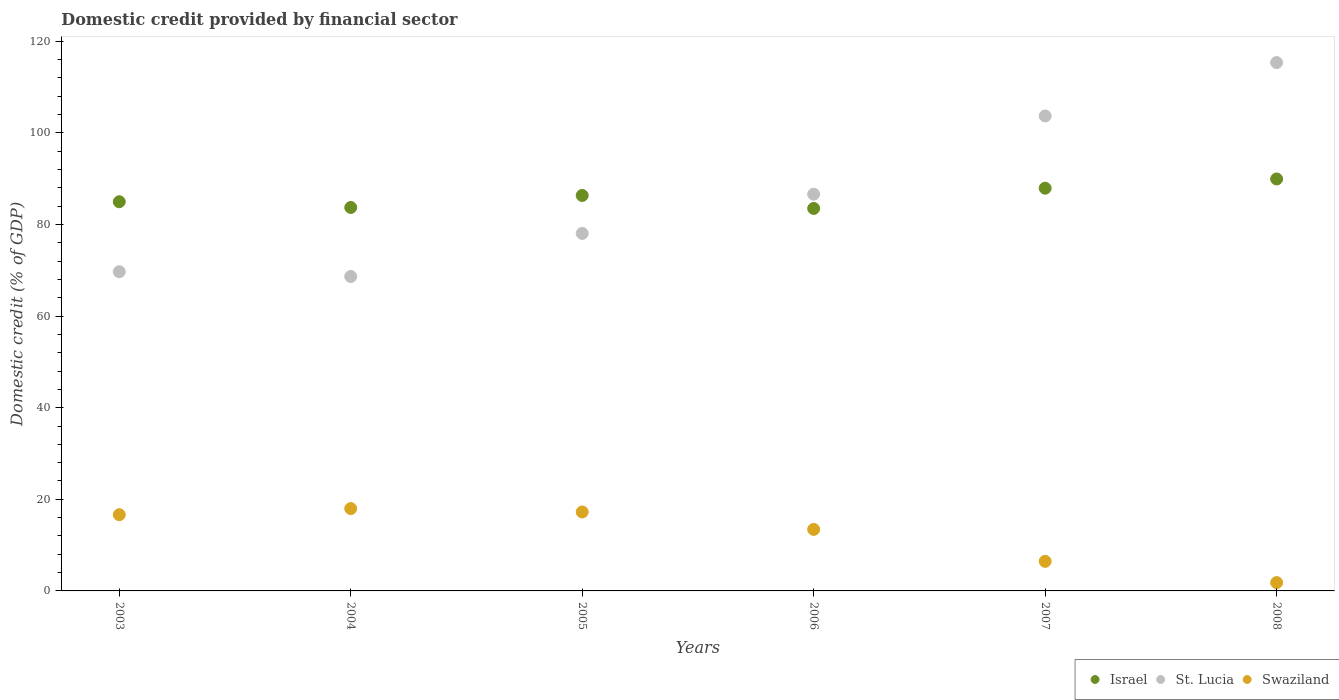What is the domestic credit in Swaziland in 2006?
Your answer should be very brief. 13.43. Across all years, what is the maximum domestic credit in St. Lucia?
Your response must be concise. 115.35. Across all years, what is the minimum domestic credit in Israel?
Make the answer very short. 83.51. In which year was the domestic credit in St. Lucia maximum?
Ensure brevity in your answer.  2008. What is the total domestic credit in St. Lucia in the graph?
Your response must be concise. 522.05. What is the difference between the domestic credit in Israel in 2003 and that in 2008?
Your answer should be very brief. -4.97. What is the difference between the domestic credit in St. Lucia in 2006 and the domestic credit in Israel in 2003?
Provide a succinct answer. 1.64. What is the average domestic credit in Swaziland per year?
Provide a short and direct response. 12.26. In the year 2003, what is the difference between the domestic credit in Israel and domestic credit in St. Lucia?
Your answer should be very brief. 15.28. In how many years, is the domestic credit in Swaziland greater than 32 %?
Give a very brief answer. 0. What is the ratio of the domestic credit in Swaziland in 2005 to that in 2007?
Offer a terse response. 2.67. What is the difference between the highest and the second highest domestic credit in St. Lucia?
Ensure brevity in your answer.  11.65. What is the difference between the highest and the lowest domestic credit in St. Lucia?
Offer a terse response. 46.7. In how many years, is the domestic credit in Israel greater than the average domestic credit in Israel taken over all years?
Your response must be concise. 3. What is the difference between two consecutive major ticks on the Y-axis?
Provide a succinct answer. 20. Does the graph contain grids?
Your response must be concise. No. Where does the legend appear in the graph?
Make the answer very short. Bottom right. How are the legend labels stacked?
Offer a very short reply. Horizontal. What is the title of the graph?
Your answer should be compact. Domestic credit provided by financial sector. What is the label or title of the Y-axis?
Offer a terse response. Domestic credit (% of GDP). What is the Domestic credit (% of GDP) in Israel in 2003?
Provide a short and direct response. 84.97. What is the Domestic credit (% of GDP) in St. Lucia in 2003?
Give a very brief answer. 69.7. What is the Domestic credit (% of GDP) in Swaziland in 2003?
Your answer should be very brief. 16.64. What is the Domestic credit (% of GDP) of Israel in 2004?
Your response must be concise. 83.72. What is the Domestic credit (% of GDP) in St. Lucia in 2004?
Offer a terse response. 68.65. What is the Domestic credit (% of GDP) in Swaziland in 2004?
Keep it short and to the point. 17.98. What is the Domestic credit (% of GDP) in Israel in 2005?
Make the answer very short. 86.34. What is the Domestic credit (% of GDP) of St. Lucia in 2005?
Keep it short and to the point. 78.05. What is the Domestic credit (% of GDP) in Swaziland in 2005?
Provide a short and direct response. 17.24. What is the Domestic credit (% of GDP) in Israel in 2006?
Keep it short and to the point. 83.51. What is the Domestic credit (% of GDP) of St. Lucia in 2006?
Make the answer very short. 86.61. What is the Domestic credit (% of GDP) in Swaziland in 2006?
Offer a very short reply. 13.43. What is the Domestic credit (% of GDP) of Israel in 2007?
Your answer should be compact. 87.92. What is the Domestic credit (% of GDP) in St. Lucia in 2007?
Provide a short and direct response. 103.7. What is the Domestic credit (% of GDP) in Swaziland in 2007?
Give a very brief answer. 6.46. What is the Domestic credit (% of GDP) of Israel in 2008?
Your answer should be very brief. 89.94. What is the Domestic credit (% of GDP) of St. Lucia in 2008?
Provide a short and direct response. 115.35. What is the Domestic credit (% of GDP) in Swaziland in 2008?
Ensure brevity in your answer.  1.82. Across all years, what is the maximum Domestic credit (% of GDP) in Israel?
Ensure brevity in your answer.  89.94. Across all years, what is the maximum Domestic credit (% of GDP) of St. Lucia?
Make the answer very short. 115.35. Across all years, what is the maximum Domestic credit (% of GDP) in Swaziland?
Keep it short and to the point. 17.98. Across all years, what is the minimum Domestic credit (% of GDP) in Israel?
Give a very brief answer. 83.51. Across all years, what is the minimum Domestic credit (% of GDP) of St. Lucia?
Provide a short and direct response. 68.65. Across all years, what is the minimum Domestic credit (% of GDP) of Swaziland?
Your response must be concise. 1.82. What is the total Domestic credit (% of GDP) in Israel in the graph?
Offer a very short reply. 516.39. What is the total Domestic credit (% of GDP) of St. Lucia in the graph?
Make the answer very short. 522.05. What is the total Domestic credit (% of GDP) in Swaziland in the graph?
Offer a terse response. 73.56. What is the difference between the Domestic credit (% of GDP) of Israel in 2003 and that in 2004?
Offer a very short reply. 1.26. What is the difference between the Domestic credit (% of GDP) in St. Lucia in 2003 and that in 2004?
Keep it short and to the point. 1.05. What is the difference between the Domestic credit (% of GDP) in Swaziland in 2003 and that in 2004?
Your response must be concise. -1.33. What is the difference between the Domestic credit (% of GDP) in Israel in 2003 and that in 2005?
Provide a short and direct response. -1.37. What is the difference between the Domestic credit (% of GDP) of St. Lucia in 2003 and that in 2005?
Your answer should be compact. -8.36. What is the difference between the Domestic credit (% of GDP) of Swaziland in 2003 and that in 2005?
Ensure brevity in your answer.  -0.59. What is the difference between the Domestic credit (% of GDP) in Israel in 2003 and that in 2006?
Your answer should be very brief. 1.47. What is the difference between the Domestic credit (% of GDP) in St. Lucia in 2003 and that in 2006?
Give a very brief answer. -16.92. What is the difference between the Domestic credit (% of GDP) in Swaziland in 2003 and that in 2006?
Offer a very short reply. 3.22. What is the difference between the Domestic credit (% of GDP) of Israel in 2003 and that in 2007?
Provide a succinct answer. -2.95. What is the difference between the Domestic credit (% of GDP) in St. Lucia in 2003 and that in 2007?
Make the answer very short. -34. What is the difference between the Domestic credit (% of GDP) in Swaziland in 2003 and that in 2007?
Ensure brevity in your answer.  10.18. What is the difference between the Domestic credit (% of GDP) of Israel in 2003 and that in 2008?
Keep it short and to the point. -4.97. What is the difference between the Domestic credit (% of GDP) in St. Lucia in 2003 and that in 2008?
Your response must be concise. -45.65. What is the difference between the Domestic credit (% of GDP) of Swaziland in 2003 and that in 2008?
Give a very brief answer. 14.83. What is the difference between the Domestic credit (% of GDP) in Israel in 2004 and that in 2005?
Provide a short and direct response. -2.62. What is the difference between the Domestic credit (% of GDP) of St. Lucia in 2004 and that in 2005?
Your response must be concise. -9.4. What is the difference between the Domestic credit (% of GDP) of Swaziland in 2004 and that in 2005?
Your answer should be very brief. 0.74. What is the difference between the Domestic credit (% of GDP) in Israel in 2004 and that in 2006?
Your answer should be compact. 0.21. What is the difference between the Domestic credit (% of GDP) of St. Lucia in 2004 and that in 2006?
Provide a short and direct response. -17.97. What is the difference between the Domestic credit (% of GDP) of Swaziland in 2004 and that in 2006?
Offer a very short reply. 4.55. What is the difference between the Domestic credit (% of GDP) of Israel in 2004 and that in 2007?
Your answer should be very brief. -4.21. What is the difference between the Domestic credit (% of GDP) in St. Lucia in 2004 and that in 2007?
Keep it short and to the point. -35.05. What is the difference between the Domestic credit (% of GDP) of Swaziland in 2004 and that in 2007?
Provide a short and direct response. 11.52. What is the difference between the Domestic credit (% of GDP) of Israel in 2004 and that in 2008?
Your response must be concise. -6.22. What is the difference between the Domestic credit (% of GDP) in St. Lucia in 2004 and that in 2008?
Keep it short and to the point. -46.7. What is the difference between the Domestic credit (% of GDP) of Swaziland in 2004 and that in 2008?
Ensure brevity in your answer.  16.16. What is the difference between the Domestic credit (% of GDP) of Israel in 2005 and that in 2006?
Give a very brief answer. 2.83. What is the difference between the Domestic credit (% of GDP) of St. Lucia in 2005 and that in 2006?
Make the answer very short. -8.56. What is the difference between the Domestic credit (% of GDP) in Swaziland in 2005 and that in 2006?
Make the answer very short. 3.81. What is the difference between the Domestic credit (% of GDP) of Israel in 2005 and that in 2007?
Your response must be concise. -1.58. What is the difference between the Domestic credit (% of GDP) in St. Lucia in 2005 and that in 2007?
Give a very brief answer. -25.64. What is the difference between the Domestic credit (% of GDP) of Swaziland in 2005 and that in 2007?
Provide a short and direct response. 10.78. What is the difference between the Domestic credit (% of GDP) of Israel in 2005 and that in 2008?
Your answer should be very brief. -3.6. What is the difference between the Domestic credit (% of GDP) of St. Lucia in 2005 and that in 2008?
Offer a very short reply. -37.3. What is the difference between the Domestic credit (% of GDP) in Swaziland in 2005 and that in 2008?
Provide a short and direct response. 15.42. What is the difference between the Domestic credit (% of GDP) in Israel in 2006 and that in 2007?
Offer a very short reply. -4.42. What is the difference between the Domestic credit (% of GDP) of St. Lucia in 2006 and that in 2007?
Your response must be concise. -17.08. What is the difference between the Domestic credit (% of GDP) of Swaziland in 2006 and that in 2007?
Your answer should be compact. 6.97. What is the difference between the Domestic credit (% of GDP) in Israel in 2006 and that in 2008?
Keep it short and to the point. -6.43. What is the difference between the Domestic credit (% of GDP) in St. Lucia in 2006 and that in 2008?
Your answer should be very brief. -28.73. What is the difference between the Domestic credit (% of GDP) of Swaziland in 2006 and that in 2008?
Provide a succinct answer. 11.61. What is the difference between the Domestic credit (% of GDP) in Israel in 2007 and that in 2008?
Your response must be concise. -2.02. What is the difference between the Domestic credit (% of GDP) of St. Lucia in 2007 and that in 2008?
Give a very brief answer. -11.65. What is the difference between the Domestic credit (% of GDP) of Swaziland in 2007 and that in 2008?
Your answer should be very brief. 4.64. What is the difference between the Domestic credit (% of GDP) in Israel in 2003 and the Domestic credit (% of GDP) in St. Lucia in 2004?
Provide a short and direct response. 16.32. What is the difference between the Domestic credit (% of GDP) in Israel in 2003 and the Domestic credit (% of GDP) in Swaziland in 2004?
Your response must be concise. 67. What is the difference between the Domestic credit (% of GDP) of St. Lucia in 2003 and the Domestic credit (% of GDP) of Swaziland in 2004?
Ensure brevity in your answer.  51.72. What is the difference between the Domestic credit (% of GDP) of Israel in 2003 and the Domestic credit (% of GDP) of St. Lucia in 2005?
Your response must be concise. 6.92. What is the difference between the Domestic credit (% of GDP) of Israel in 2003 and the Domestic credit (% of GDP) of Swaziland in 2005?
Your answer should be very brief. 67.73. What is the difference between the Domestic credit (% of GDP) in St. Lucia in 2003 and the Domestic credit (% of GDP) in Swaziland in 2005?
Offer a very short reply. 52.46. What is the difference between the Domestic credit (% of GDP) in Israel in 2003 and the Domestic credit (% of GDP) in St. Lucia in 2006?
Offer a terse response. -1.64. What is the difference between the Domestic credit (% of GDP) in Israel in 2003 and the Domestic credit (% of GDP) in Swaziland in 2006?
Make the answer very short. 71.54. What is the difference between the Domestic credit (% of GDP) in St. Lucia in 2003 and the Domestic credit (% of GDP) in Swaziland in 2006?
Offer a terse response. 56.27. What is the difference between the Domestic credit (% of GDP) of Israel in 2003 and the Domestic credit (% of GDP) of St. Lucia in 2007?
Your answer should be compact. -18.72. What is the difference between the Domestic credit (% of GDP) in Israel in 2003 and the Domestic credit (% of GDP) in Swaziland in 2007?
Provide a short and direct response. 78.51. What is the difference between the Domestic credit (% of GDP) of St. Lucia in 2003 and the Domestic credit (% of GDP) of Swaziland in 2007?
Your response must be concise. 63.24. What is the difference between the Domestic credit (% of GDP) of Israel in 2003 and the Domestic credit (% of GDP) of St. Lucia in 2008?
Make the answer very short. -30.38. What is the difference between the Domestic credit (% of GDP) of Israel in 2003 and the Domestic credit (% of GDP) of Swaziland in 2008?
Provide a succinct answer. 83.15. What is the difference between the Domestic credit (% of GDP) in St. Lucia in 2003 and the Domestic credit (% of GDP) in Swaziland in 2008?
Your response must be concise. 67.88. What is the difference between the Domestic credit (% of GDP) of Israel in 2004 and the Domestic credit (% of GDP) of St. Lucia in 2005?
Offer a very short reply. 5.66. What is the difference between the Domestic credit (% of GDP) of Israel in 2004 and the Domestic credit (% of GDP) of Swaziland in 2005?
Keep it short and to the point. 66.48. What is the difference between the Domestic credit (% of GDP) of St. Lucia in 2004 and the Domestic credit (% of GDP) of Swaziland in 2005?
Ensure brevity in your answer.  51.41. What is the difference between the Domestic credit (% of GDP) in Israel in 2004 and the Domestic credit (% of GDP) in St. Lucia in 2006?
Make the answer very short. -2.9. What is the difference between the Domestic credit (% of GDP) in Israel in 2004 and the Domestic credit (% of GDP) in Swaziland in 2006?
Give a very brief answer. 70.29. What is the difference between the Domestic credit (% of GDP) of St. Lucia in 2004 and the Domestic credit (% of GDP) of Swaziland in 2006?
Your answer should be very brief. 55.22. What is the difference between the Domestic credit (% of GDP) of Israel in 2004 and the Domestic credit (% of GDP) of St. Lucia in 2007?
Make the answer very short. -19.98. What is the difference between the Domestic credit (% of GDP) of Israel in 2004 and the Domestic credit (% of GDP) of Swaziland in 2007?
Provide a succinct answer. 77.26. What is the difference between the Domestic credit (% of GDP) in St. Lucia in 2004 and the Domestic credit (% of GDP) in Swaziland in 2007?
Your answer should be compact. 62.19. What is the difference between the Domestic credit (% of GDP) in Israel in 2004 and the Domestic credit (% of GDP) in St. Lucia in 2008?
Your response must be concise. -31.63. What is the difference between the Domestic credit (% of GDP) of Israel in 2004 and the Domestic credit (% of GDP) of Swaziland in 2008?
Offer a very short reply. 81.9. What is the difference between the Domestic credit (% of GDP) in St. Lucia in 2004 and the Domestic credit (% of GDP) in Swaziland in 2008?
Ensure brevity in your answer.  66.83. What is the difference between the Domestic credit (% of GDP) of Israel in 2005 and the Domestic credit (% of GDP) of St. Lucia in 2006?
Ensure brevity in your answer.  -0.28. What is the difference between the Domestic credit (% of GDP) in Israel in 2005 and the Domestic credit (% of GDP) in Swaziland in 2006?
Ensure brevity in your answer.  72.91. What is the difference between the Domestic credit (% of GDP) in St. Lucia in 2005 and the Domestic credit (% of GDP) in Swaziland in 2006?
Give a very brief answer. 64.62. What is the difference between the Domestic credit (% of GDP) in Israel in 2005 and the Domestic credit (% of GDP) in St. Lucia in 2007?
Your response must be concise. -17.36. What is the difference between the Domestic credit (% of GDP) of Israel in 2005 and the Domestic credit (% of GDP) of Swaziland in 2007?
Your answer should be compact. 79.88. What is the difference between the Domestic credit (% of GDP) of St. Lucia in 2005 and the Domestic credit (% of GDP) of Swaziland in 2007?
Provide a succinct answer. 71.59. What is the difference between the Domestic credit (% of GDP) of Israel in 2005 and the Domestic credit (% of GDP) of St. Lucia in 2008?
Your answer should be very brief. -29.01. What is the difference between the Domestic credit (% of GDP) in Israel in 2005 and the Domestic credit (% of GDP) in Swaziland in 2008?
Give a very brief answer. 84.52. What is the difference between the Domestic credit (% of GDP) of St. Lucia in 2005 and the Domestic credit (% of GDP) of Swaziland in 2008?
Provide a short and direct response. 76.23. What is the difference between the Domestic credit (% of GDP) of Israel in 2006 and the Domestic credit (% of GDP) of St. Lucia in 2007?
Offer a terse response. -20.19. What is the difference between the Domestic credit (% of GDP) in Israel in 2006 and the Domestic credit (% of GDP) in Swaziland in 2007?
Your answer should be compact. 77.05. What is the difference between the Domestic credit (% of GDP) of St. Lucia in 2006 and the Domestic credit (% of GDP) of Swaziland in 2007?
Your answer should be compact. 80.15. What is the difference between the Domestic credit (% of GDP) of Israel in 2006 and the Domestic credit (% of GDP) of St. Lucia in 2008?
Offer a terse response. -31.84. What is the difference between the Domestic credit (% of GDP) of Israel in 2006 and the Domestic credit (% of GDP) of Swaziland in 2008?
Ensure brevity in your answer.  81.69. What is the difference between the Domestic credit (% of GDP) of St. Lucia in 2006 and the Domestic credit (% of GDP) of Swaziland in 2008?
Your response must be concise. 84.8. What is the difference between the Domestic credit (% of GDP) of Israel in 2007 and the Domestic credit (% of GDP) of St. Lucia in 2008?
Keep it short and to the point. -27.43. What is the difference between the Domestic credit (% of GDP) in Israel in 2007 and the Domestic credit (% of GDP) in Swaziland in 2008?
Your answer should be very brief. 86.1. What is the difference between the Domestic credit (% of GDP) of St. Lucia in 2007 and the Domestic credit (% of GDP) of Swaziland in 2008?
Your answer should be compact. 101.88. What is the average Domestic credit (% of GDP) of Israel per year?
Offer a terse response. 86.06. What is the average Domestic credit (% of GDP) in St. Lucia per year?
Provide a succinct answer. 87.01. What is the average Domestic credit (% of GDP) in Swaziland per year?
Ensure brevity in your answer.  12.26. In the year 2003, what is the difference between the Domestic credit (% of GDP) of Israel and Domestic credit (% of GDP) of St. Lucia?
Offer a very short reply. 15.28. In the year 2003, what is the difference between the Domestic credit (% of GDP) in Israel and Domestic credit (% of GDP) in Swaziland?
Your response must be concise. 68.33. In the year 2003, what is the difference between the Domestic credit (% of GDP) in St. Lucia and Domestic credit (% of GDP) in Swaziland?
Provide a succinct answer. 53.05. In the year 2004, what is the difference between the Domestic credit (% of GDP) of Israel and Domestic credit (% of GDP) of St. Lucia?
Make the answer very short. 15.07. In the year 2004, what is the difference between the Domestic credit (% of GDP) of Israel and Domestic credit (% of GDP) of Swaziland?
Provide a short and direct response. 65.74. In the year 2004, what is the difference between the Domestic credit (% of GDP) in St. Lucia and Domestic credit (% of GDP) in Swaziland?
Keep it short and to the point. 50.67. In the year 2005, what is the difference between the Domestic credit (% of GDP) in Israel and Domestic credit (% of GDP) in St. Lucia?
Offer a very short reply. 8.29. In the year 2005, what is the difference between the Domestic credit (% of GDP) in Israel and Domestic credit (% of GDP) in Swaziland?
Ensure brevity in your answer.  69.1. In the year 2005, what is the difference between the Domestic credit (% of GDP) in St. Lucia and Domestic credit (% of GDP) in Swaziland?
Your answer should be compact. 60.81. In the year 2006, what is the difference between the Domestic credit (% of GDP) in Israel and Domestic credit (% of GDP) in St. Lucia?
Make the answer very short. -3.11. In the year 2006, what is the difference between the Domestic credit (% of GDP) of Israel and Domestic credit (% of GDP) of Swaziland?
Provide a short and direct response. 70.08. In the year 2006, what is the difference between the Domestic credit (% of GDP) in St. Lucia and Domestic credit (% of GDP) in Swaziland?
Your answer should be very brief. 73.19. In the year 2007, what is the difference between the Domestic credit (% of GDP) of Israel and Domestic credit (% of GDP) of St. Lucia?
Keep it short and to the point. -15.78. In the year 2007, what is the difference between the Domestic credit (% of GDP) in Israel and Domestic credit (% of GDP) in Swaziland?
Ensure brevity in your answer.  81.46. In the year 2007, what is the difference between the Domestic credit (% of GDP) in St. Lucia and Domestic credit (% of GDP) in Swaziland?
Keep it short and to the point. 97.24. In the year 2008, what is the difference between the Domestic credit (% of GDP) of Israel and Domestic credit (% of GDP) of St. Lucia?
Offer a very short reply. -25.41. In the year 2008, what is the difference between the Domestic credit (% of GDP) in Israel and Domestic credit (% of GDP) in Swaziland?
Keep it short and to the point. 88.12. In the year 2008, what is the difference between the Domestic credit (% of GDP) of St. Lucia and Domestic credit (% of GDP) of Swaziland?
Your answer should be compact. 113.53. What is the ratio of the Domestic credit (% of GDP) in Israel in 2003 to that in 2004?
Give a very brief answer. 1.01. What is the ratio of the Domestic credit (% of GDP) of St. Lucia in 2003 to that in 2004?
Provide a succinct answer. 1.02. What is the ratio of the Domestic credit (% of GDP) in Swaziland in 2003 to that in 2004?
Offer a terse response. 0.93. What is the ratio of the Domestic credit (% of GDP) of Israel in 2003 to that in 2005?
Offer a terse response. 0.98. What is the ratio of the Domestic credit (% of GDP) of St. Lucia in 2003 to that in 2005?
Provide a short and direct response. 0.89. What is the ratio of the Domestic credit (% of GDP) in Swaziland in 2003 to that in 2005?
Give a very brief answer. 0.97. What is the ratio of the Domestic credit (% of GDP) in Israel in 2003 to that in 2006?
Your answer should be very brief. 1.02. What is the ratio of the Domestic credit (% of GDP) of St. Lucia in 2003 to that in 2006?
Your answer should be very brief. 0.8. What is the ratio of the Domestic credit (% of GDP) in Swaziland in 2003 to that in 2006?
Provide a succinct answer. 1.24. What is the ratio of the Domestic credit (% of GDP) of Israel in 2003 to that in 2007?
Give a very brief answer. 0.97. What is the ratio of the Domestic credit (% of GDP) of St. Lucia in 2003 to that in 2007?
Keep it short and to the point. 0.67. What is the ratio of the Domestic credit (% of GDP) in Swaziland in 2003 to that in 2007?
Your answer should be compact. 2.58. What is the ratio of the Domestic credit (% of GDP) of Israel in 2003 to that in 2008?
Keep it short and to the point. 0.94. What is the ratio of the Domestic credit (% of GDP) of St. Lucia in 2003 to that in 2008?
Keep it short and to the point. 0.6. What is the ratio of the Domestic credit (% of GDP) in Swaziland in 2003 to that in 2008?
Provide a short and direct response. 9.15. What is the ratio of the Domestic credit (% of GDP) in Israel in 2004 to that in 2005?
Ensure brevity in your answer.  0.97. What is the ratio of the Domestic credit (% of GDP) in St. Lucia in 2004 to that in 2005?
Provide a succinct answer. 0.88. What is the ratio of the Domestic credit (% of GDP) in Swaziland in 2004 to that in 2005?
Offer a very short reply. 1.04. What is the ratio of the Domestic credit (% of GDP) of Israel in 2004 to that in 2006?
Provide a short and direct response. 1. What is the ratio of the Domestic credit (% of GDP) in St. Lucia in 2004 to that in 2006?
Your response must be concise. 0.79. What is the ratio of the Domestic credit (% of GDP) in Swaziland in 2004 to that in 2006?
Your answer should be very brief. 1.34. What is the ratio of the Domestic credit (% of GDP) of Israel in 2004 to that in 2007?
Your response must be concise. 0.95. What is the ratio of the Domestic credit (% of GDP) of St. Lucia in 2004 to that in 2007?
Ensure brevity in your answer.  0.66. What is the ratio of the Domestic credit (% of GDP) of Swaziland in 2004 to that in 2007?
Offer a very short reply. 2.78. What is the ratio of the Domestic credit (% of GDP) in Israel in 2004 to that in 2008?
Provide a succinct answer. 0.93. What is the ratio of the Domestic credit (% of GDP) of St. Lucia in 2004 to that in 2008?
Offer a terse response. 0.6. What is the ratio of the Domestic credit (% of GDP) of Swaziland in 2004 to that in 2008?
Give a very brief answer. 9.88. What is the ratio of the Domestic credit (% of GDP) in Israel in 2005 to that in 2006?
Your response must be concise. 1.03. What is the ratio of the Domestic credit (% of GDP) in St. Lucia in 2005 to that in 2006?
Your answer should be compact. 0.9. What is the ratio of the Domestic credit (% of GDP) in Swaziland in 2005 to that in 2006?
Your answer should be compact. 1.28. What is the ratio of the Domestic credit (% of GDP) of St. Lucia in 2005 to that in 2007?
Offer a terse response. 0.75. What is the ratio of the Domestic credit (% of GDP) of Swaziland in 2005 to that in 2007?
Your answer should be very brief. 2.67. What is the ratio of the Domestic credit (% of GDP) in Israel in 2005 to that in 2008?
Your response must be concise. 0.96. What is the ratio of the Domestic credit (% of GDP) in St. Lucia in 2005 to that in 2008?
Ensure brevity in your answer.  0.68. What is the ratio of the Domestic credit (% of GDP) of Swaziland in 2005 to that in 2008?
Make the answer very short. 9.48. What is the ratio of the Domestic credit (% of GDP) in Israel in 2006 to that in 2007?
Your answer should be compact. 0.95. What is the ratio of the Domestic credit (% of GDP) in St. Lucia in 2006 to that in 2007?
Your answer should be compact. 0.84. What is the ratio of the Domestic credit (% of GDP) in Swaziland in 2006 to that in 2007?
Make the answer very short. 2.08. What is the ratio of the Domestic credit (% of GDP) in Israel in 2006 to that in 2008?
Your answer should be very brief. 0.93. What is the ratio of the Domestic credit (% of GDP) of St. Lucia in 2006 to that in 2008?
Your response must be concise. 0.75. What is the ratio of the Domestic credit (% of GDP) in Swaziland in 2006 to that in 2008?
Offer a very short reply. 7.38. What is the ratio of the Domestic credit (% of GDP) in Israel in 2007 to that in 2008?
Provide a succinct answer. 0.98. What is the ratio of the Domestic credit (% of GDP) of St. Lucia in 2007 to that in 2008?
Your answer should be very brief. 0.9. What is the ratio of the Domestic credit (% of GDP) of Swaziland in 2007 to that in 2008?
Give a very brief answer. 3.55. What is the difference between the highest and the second highest Domestic credit (% of GDP) of Israel?
Ensure brevity in your answer.  2.02. What is the difference between the highest and the second highest Domestic credit (% of GDP) in St. Lucia?
Offer a very short reply. 11.65. What is the difference between the highest and the second highest Domestic credit (% of GDP) of Swaziland?
Offer a terse response. 0.74. What is the difference between the highest and the lowest Domestic credit (% of GDP) in Israel?
Provide a short and direct response. 6.43. What is the difference between the highest and the lowest Domestic credit (% of GDP) of St. Lucia?
Your answer should be compact. 46.7. What is the difference between the highest and the lowest Domestic credit (% of GDP) in Swaziland?
Your answer should be compact. 16.16. 